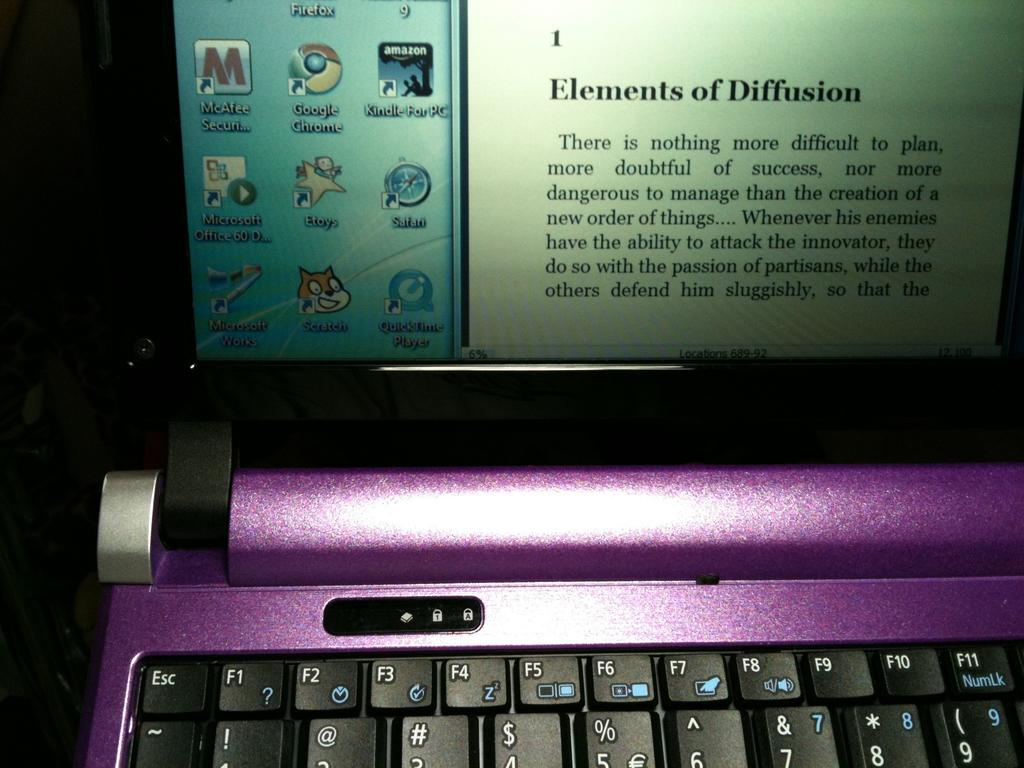Provide a one-sentence caption for the provided image. A purple flip screen computer has a paragraph on Elements of Diffusion on screen. 